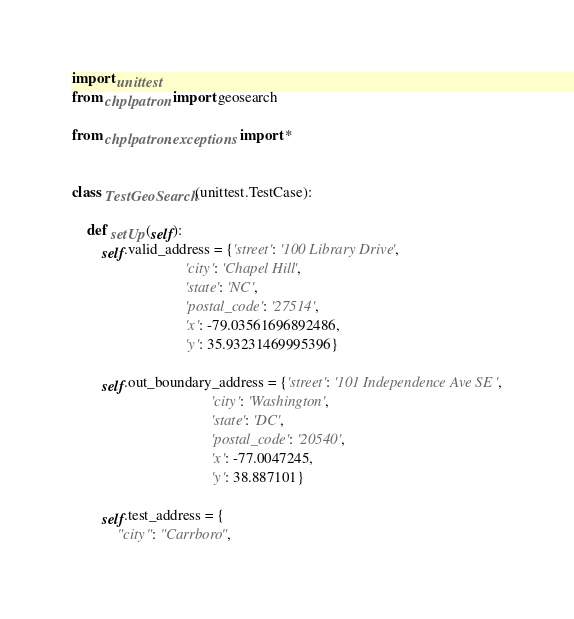<code> <loc_0><loc_0><loc_500><loc_500><_Python_>import unittest
from chplpatron import geosearch

from chplpatron.exceptions import *


class TestGeoSearch(unittest.TestCase):

    def setUp(self):
        self.valid_address = {'street': '100 Library Drive',
                              'city': 'Chapel Hill',
                              'state': 'NC',
                              'postal_code': '27514',
                              'x': -79.03561696892486,
                              'y': 35.93231469995396}

        self.out_boundary_address = {'street': '101 Independence Ave SE',
                                     'city': 'Washington',
                                     'state': 'DC',
                                     'postal_code': '20540',
                                     'x': -77.0047245,
                                     'y': 38.887101}

        self.test_address = {
            "city": "Carrboro",</code> 